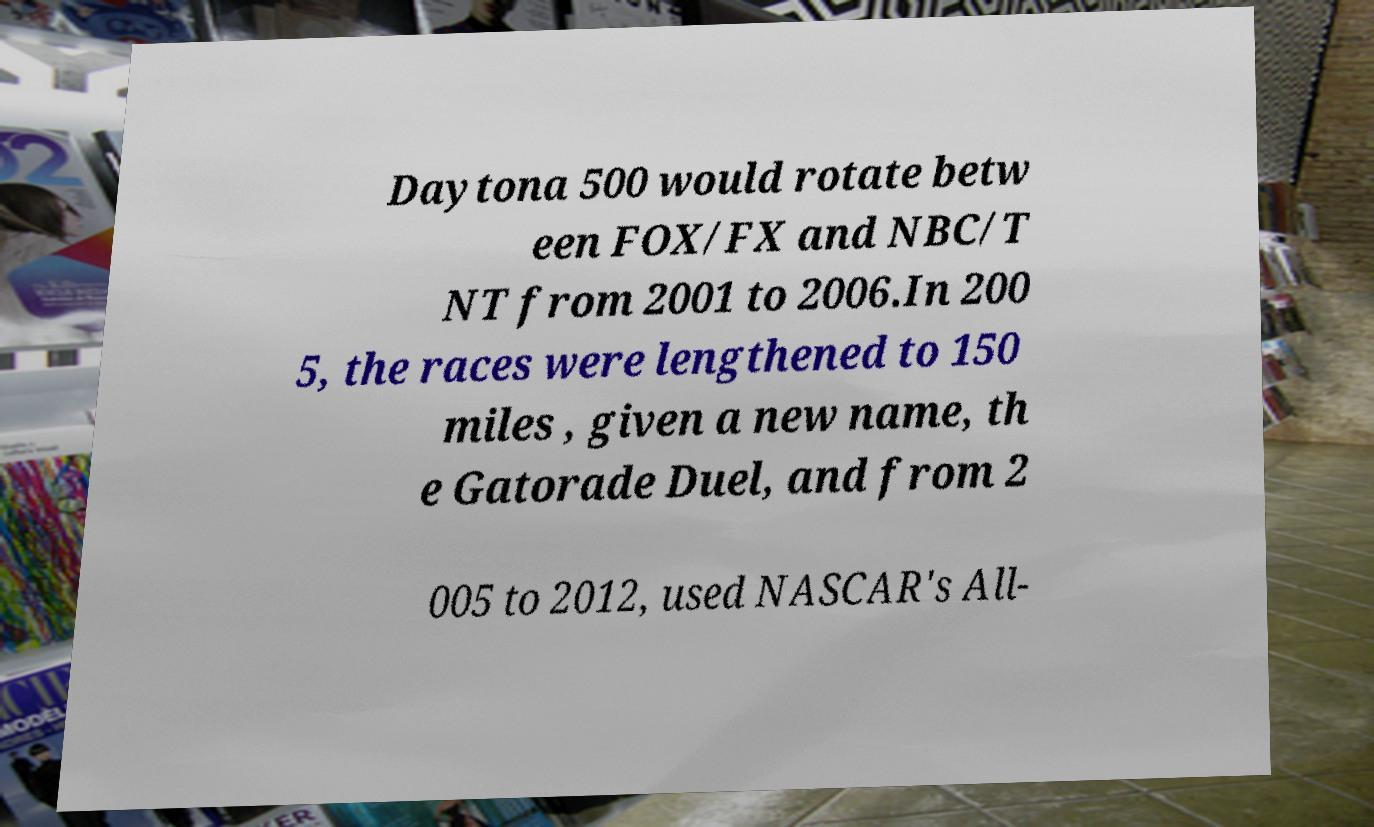I need the written content from this picture converted into text. Can you do that? Daytona 500 would rotate betw een FOX/FX and NBC/T NT from 2001 to 2006.In 200 5, the races were lengthened to 150 miles , given a new name, th e Gatorade Duel, and from 2 005 to 2012, used NASCAR's All- 